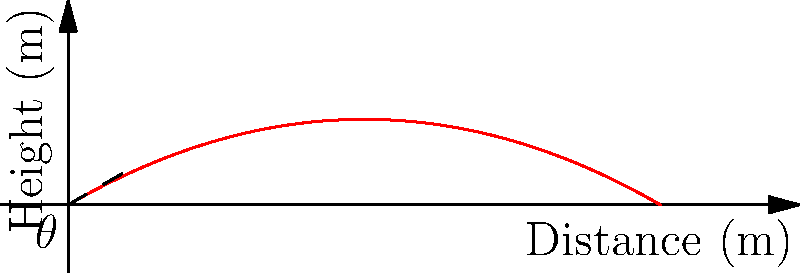In a crime scene reconstruction, a forensic ballistics expert needs to calculate the maximum height reached by a bullet fired from a gun. The gun is fired at an angle of 30° to the horizontal with an initial velocity of 50 m/s. Assuming air resistance is negligible, what is the maximum height reached by the bullet? (Use g = 9.8 m/s²) To solve this problem, we'll follow these steps:

1. Identify the relevant equations:
   - For maximum height: $h_{max} = \frac{v_0^2 \sin^2\theta}{2g}$
   Where $v_0$ is the initial velocity, $\theta$ is the angle, and $g$ is the acceleration due to gravity.

2. Given information:
   - Initial velocity, $v_0 = 50$ m/s
   - Angle, $\theta = 30°$
   - Acceleration due to gravity, $g = 9.8$ m/s²

3. Convert the angle to radians:
   $30° = 30 \times \frac{\pi}{180} = \frac{\pi}{6}$ radians

4. Calculate $\sin^2\theta$:
   $\sin^2(\frac{\pi}{6}) = (\frac{1}{2})^2 = \frac{1}{4}$

5. Substitute the values into the equation:
   $h_{max} = \frac{(50\,\text{m/s})^2 \times \frac{1}{4}}{2 \times 9.8\,\text{m/s}^2}$

6. Simplify:
   $h_{max} = \frac{2500\,\text{m}^2\text{/s}^2 \times \frac{1}{4}}{19.6\,\text{m/s}^2} = \frac{625\,\text{m}^2\text{/s}^2}{19.6\,\text{m/s}^2}$

7. Calculate the final result:
   $h_{max} \approx 31.89$ m

Therefore, the maximum height reached by the bullet is approximately 31.89 meters.
Answer: 31.89 m 